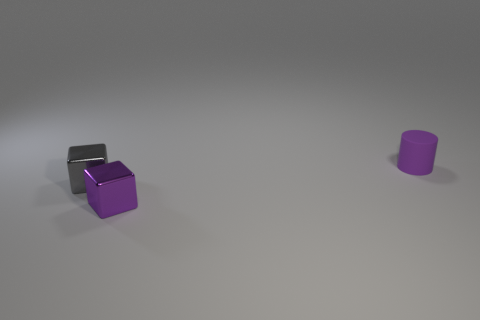Add 2 tiny purple matte cylinders. How many objects exist? 5 Subtract 1 purple cylinders. How many objects are left? 2 Subtract all blocks. How many objects are left? 1 Subtract all tiny gray shiny cubes. Subtract all purple metal blocks. How many objects are left? 1 Add 1 tiny gray metallic things. How many tiny gray metallic things are left? 2 Add 2 tiny green metallic things. How many tiny green metallic things exist? 2 